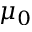Convert formula to latex. <formula><loc_0><loc_0><loc_500><loc_500>\mu _ { 0 }</formula> 